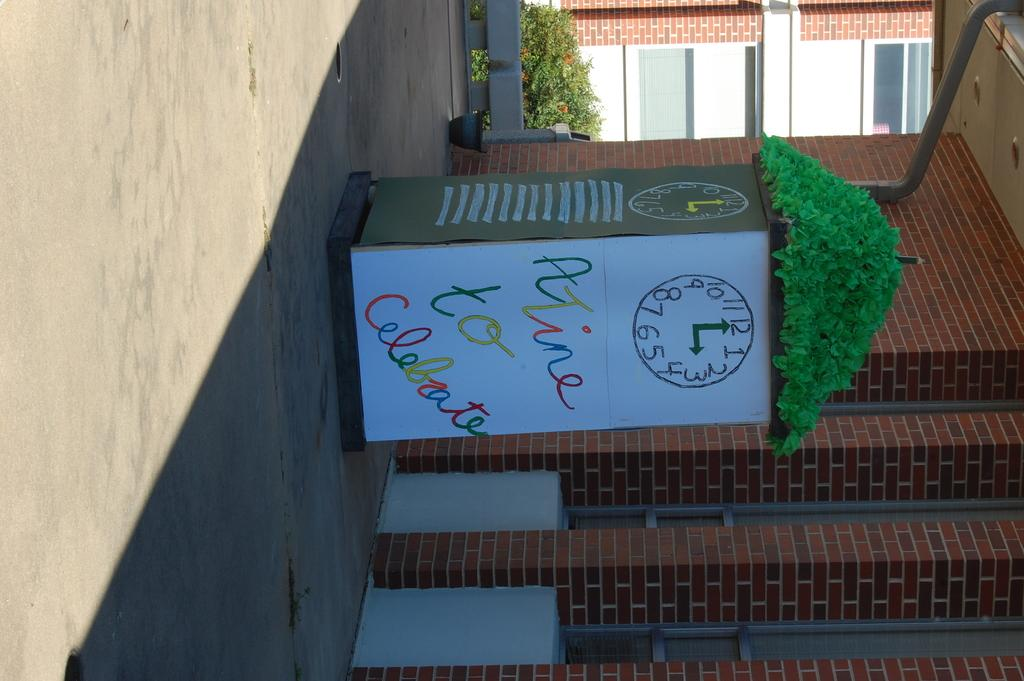What can be seen running through the image? There is a path in the image. What is located on the path? There is a box on the path. What is inside the box? The box contains a black sheet and a white sheet. What is depicted on the sheets? There is a clock image drawn on the sheets. What structure is near the box? There is a house beside the box. What type of theory does the minister propose about the fang in the image? There is no minister, theory, or fang present in the image. 